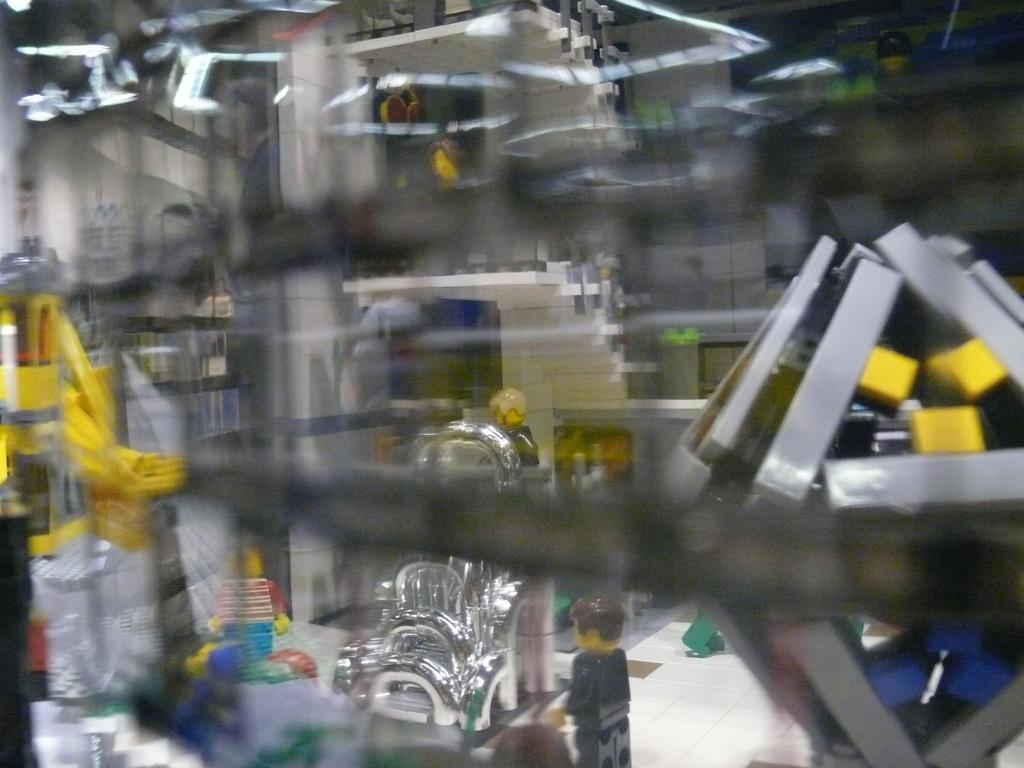What is the overall quality of the image? The image is blurry. What type of objects can be seen in the image? There are miniatures and machines in the image. Are there any items on the floor in the image? Yes, there are items on the floor in the image. What type of stew is being prepared in the image? There is no stew present in the image; it features miniatures, machines, and items on the floor. Can you see a toothbrush in the image? There is no toothbrush present in the image. 